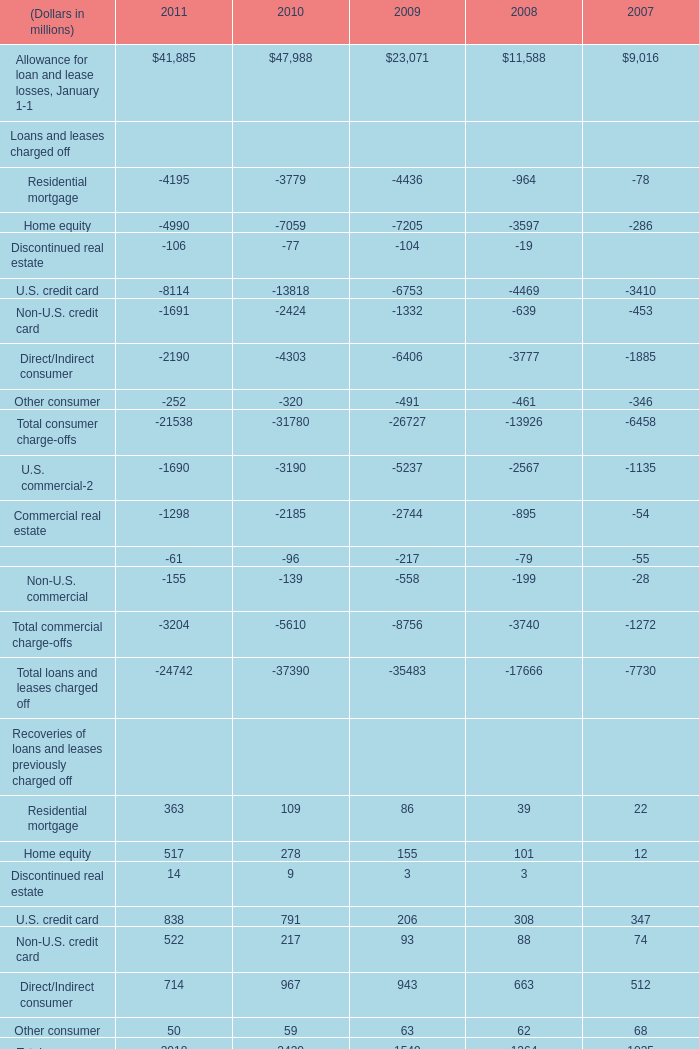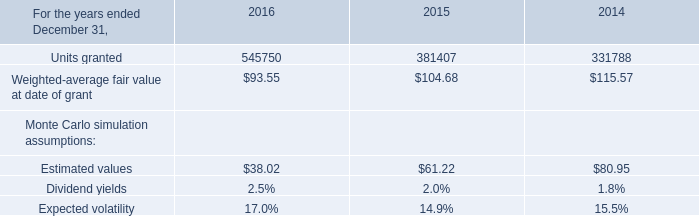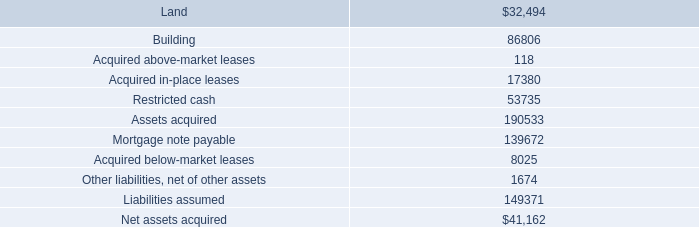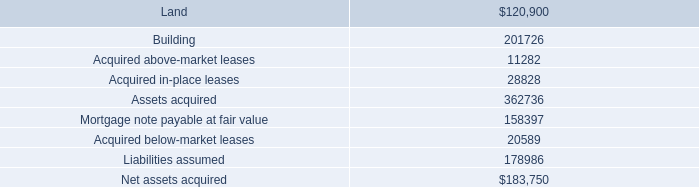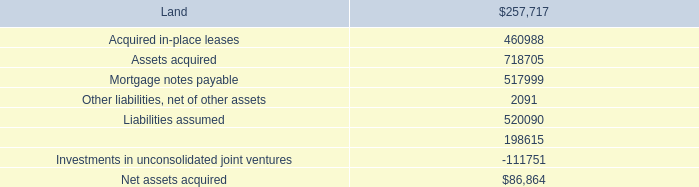What is the average amount of Units granted of 2016, and U.S. commercial Loans and leases charged off of 2009 ? 
Computations: ((545750.0 + 5237.0) / 2)
Answer: 275493.5. 